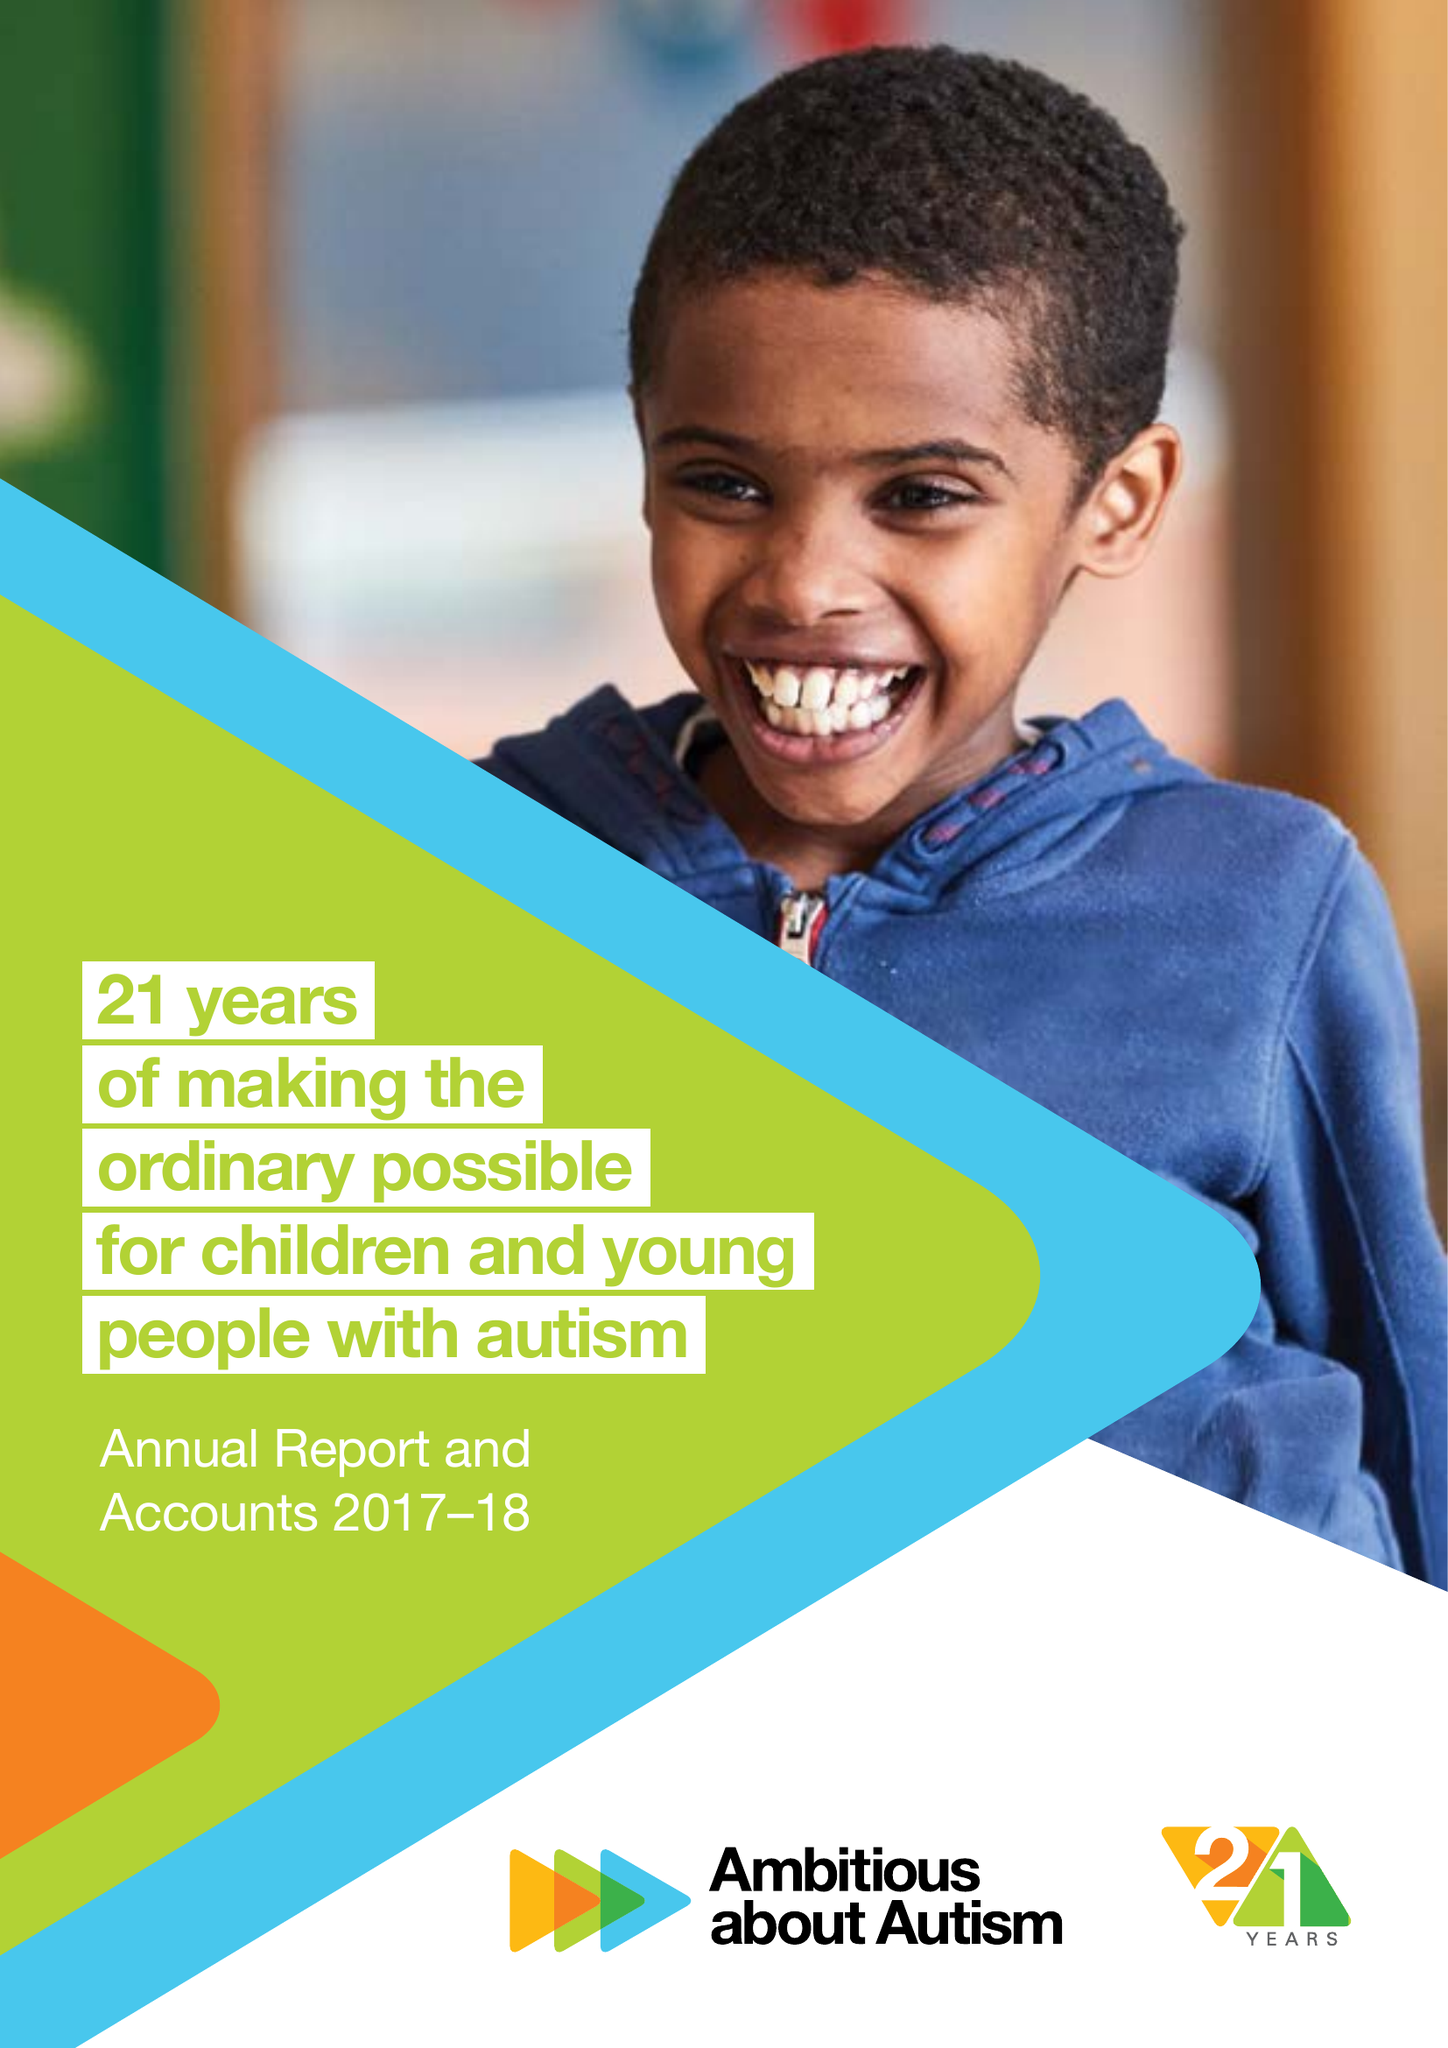What is the value for the address__street_line?
Answer the question using a single word or phrase. WOODSIDE AVENUE 